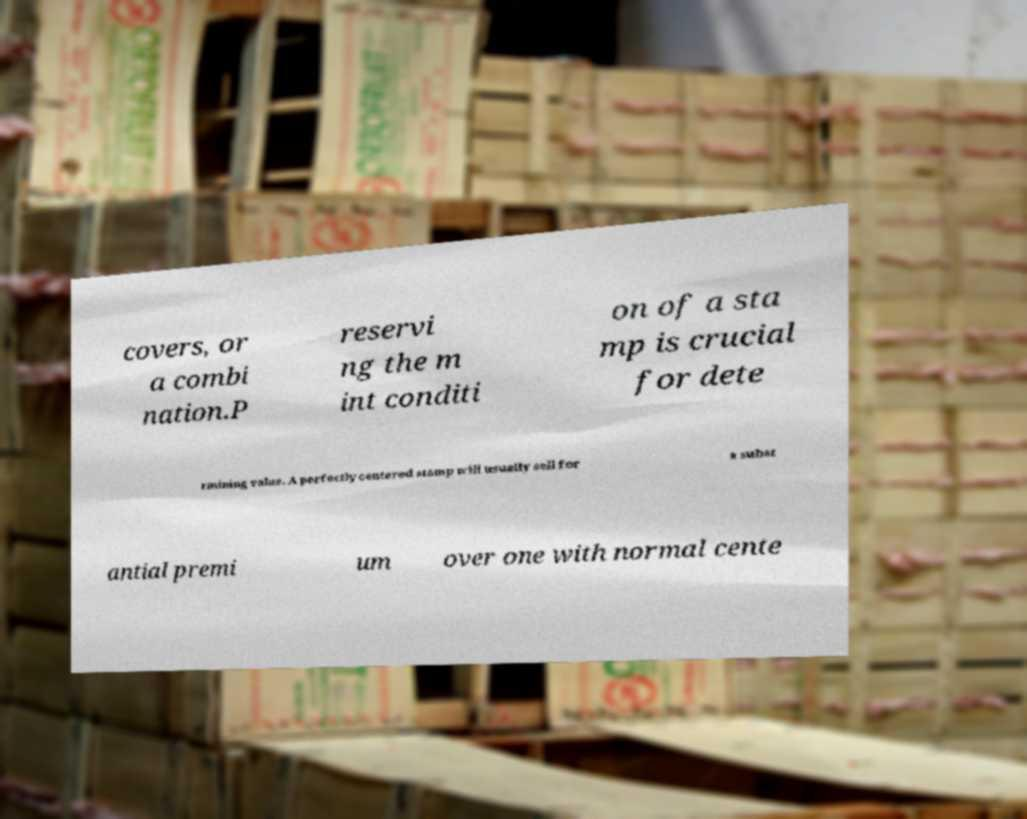Please identify and transcribe the text found in this image. covers, or a combi nation.P reservi ng the m int conditi on of a sta mp is crucial for dete rmining value. A perfectly centered stamp will usually sell for a subst antial premi um over one with normal cente 